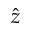<formula> <loc_0><loc_0><loc_500><loc_500>\hat { z }</formula> 